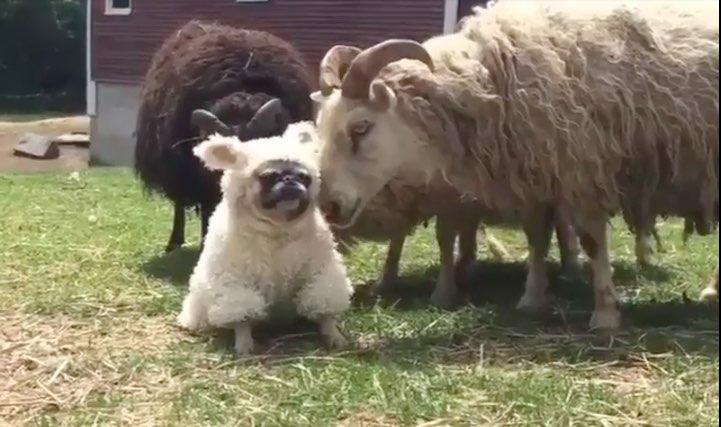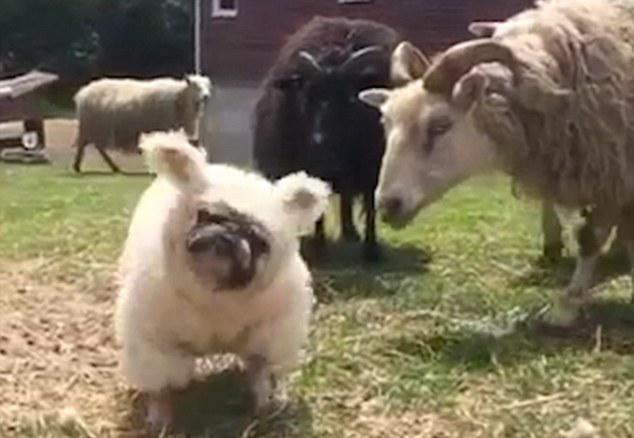The first image is the image on the left, the second image is the image on the right. Considering the images on both sides, is "A dog is shown near some sheep." valid? Answer yes or no. Yes. The first image is the image on the left, the second image is the image on the right. Evaluate the accuracy of this statement regarding the images: "Only one of the images shows a dog wearing animal-themed attire.". Is it true? Answer yes or no. No. 